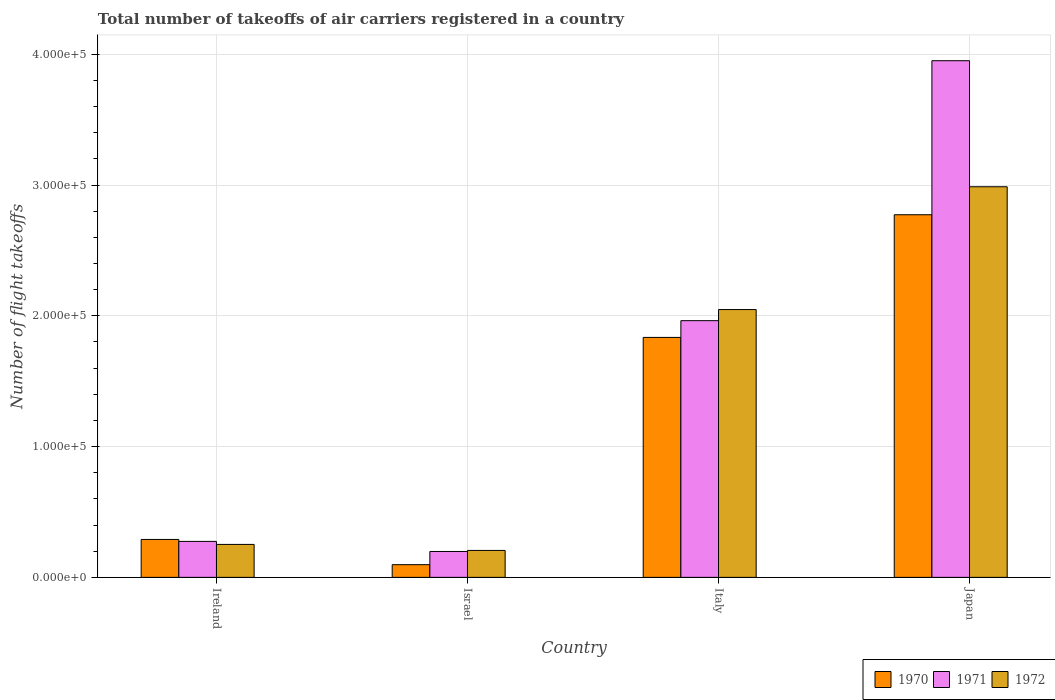How many different coloured bars are there?
Your answer should be compact. 3. How many groups of bars are there?
Provide a succinct answer. 4. How many bars are there on the 4th tick from the left?
Make the answer very short. 3. What is the label of the 2nd group of bars from the left?
Make the answer very short. Israel. In how many cases, is the number of bars for a given country not equal to the number of legend labels?
Your response must be concise. 0. What is the total number of flight takeoffs in 1971 in Italy?
Your response must be concise. 1.96e+05. Across all countries, what is the maximum total number of flight takeoffs in 1972?
Ensure brevity in your answer.  2.99e+05. Across all countries, what is the minimum total number of flight takeoffs in 1972?
Provide a short and direct response. 2.06e+04. In which country was the total number of flight takeoffs in 1970 maximum?
Ensure brevity in your answer.  Japan. In which country was the total number of flight takeoffs in 1972 minimum?
Offer a terse response. Israel. What is the total total number of flight takeoffs in 1970 in the graph?
Provide a succinct answer. 5.00e+05. What is the difference between the total number of flight takeoffs in 1972 in Italy and that in Japan?
Provide a succinct answer. -9.39e+04. What is the difference between the total number of flight takeoffs in 1971 in Ireland and the total number of flight takeoffs in 1970 in Japan?
Give a very brief answer. -2.50e+05. What is the average total number of flight takeoffs in 1970 per country?
Provide a short and direct response. 1.25e+05. What is the difference between the total number of flight takeoffs of/in 1970 and total number of flight takeoffs of/in 1971 in Japan?
Give a very brief answer. -1.18e+05. In how many countries, is the total number of flight takeoffs in 1972 greater than 280000?
Provide a short and direct response. 1. What is the ratio of the total number of flight takeoffs in 1972 in Ireland to that in Japan?
Keep it short and to the point. 0.08. Is the difference between the total number of flight takeoffs in 1970 in Ireland and Israel greater than the difference between the total number of flight takeoffs in 1971 in Ireland and Israel?
Your answer should be very brief. Yes. What is the difference between the highest and the second highest total number of flight takeoffs in 1970?
Your response must be concise. -1.54e+05. What is the difference between the highest and the lowest total number of flight takeoffs in 1972?
Provide a succinct answer. 2.78e+05. Is the sum of the total number of flight takeoffs in 1970 in Ireland and Japan greater than the maximum total number of flight takeoffs in 1972 across all countries?
Provide a short and direct response. Yes. What does the 1st bar from the right in Israel represents?
Your answer should be very brief. 1972. How many bars are there?
Your answer should be compact. 12. Are all the bars in the graph horizontal?
Provide a succinct answer. No. Are the values on the major ticks of Y-axis written in scientific E-notation?
Make the answer very short. Yes. Does the graph contain grids?
Offer a very short reply. Yes. What is the title of the graph?
Your answer should be very brief. Total number of takeoffs of air carriers registered in a country. Does "1988" appear as one of the legend labels in the graph?
Your answer should be compact. No. What is the label or title of the X-axis?
Offer a very short reply. Country. What is the label or title of the Y-axis?
Make the answer very short. Number of flight takeoffs. What is the Number of flight takeoffs of 1970 in Ireland?
Your answer should be compact. 2.90e+04. What is the Number of flight takeoffs in 1971 in Ireland?
Your response must be concise. 2.75e+04. What is the Number of flight takeoffs in 1972 in Ireland?
Provide a succinct answer. 2.52e+04. What is the Number of flight takeoffs in 1970 in Israel?
Offer a very short reply. 9700. What is the Number of flight takeoffs in 1971 in Israel?
Offer a terse response. 1.98e+04. What is the Number of flight takeoffs in 1972 in Israel?
Provide a succinct answer. 2.06e+04. What is the Number of flight takeoffs in 1970 in Italy?
Provide a short and direct response. 1.84e+05. What is the Number of flight takeoffs of 1971 in Italy?
Offer a very short reply. 1.96e+05. What is the Number of flight takeoffs of 1972 in Italy?
Give a very brief answer. 2.05e+05. What is the Number of flight takeoffs of 1970 in Japan?
Provide a succinct answer. 2.77e+05. What is the Number of flight takeoffs of 1971 in Japan?
Provide a short and direct response. 3.95e+05. What is the Number of flight takeoffs of 1972 in Japan?
Give a very brief answer. 2.99e+05. Across all countries, what is the maximum Number of flight takeoffs of 1970?
Offer a terse response. 2.77e+05. Across all countries, what is the maximum Number of flight takeoffs in 1971?
Give a very brief answer. 3.95e+05. Across all countries, what is the maximum Number of flight takeoffs of 1972?
Keep it short and to the point. 2.99e+05. Across all countries, what is the minimum Number of flight takeoffs of 1970?
Provide a succinct answer. 9700. Across all countries, what is the minimum Number of flight takeoffs of 1971?
Ensure brevity in your answer.  1.98e+04. Across all countries, what is the minimum Number of flight takeoffs of 1972?
Keep it short and to the point. 2.06e+04. What is the total Number of flight takeoffs in 1970 in the graph?
Ensure brevity in your answer.  5.00e+05. What is the total Number of flight takeoffs of 1971 in the graph?
Keep it short and to the point. 6.39e+05. What is the total Number of flight takeoffs in 1972 in the graph?
Provide a succinct answer. 5.49e+05. What is the difference between the Number of flight takeoffs of 1970 in Ireland and that in Israel?
Provide a succinct answer. 1.93e+04. What is the difference between the Number of flight takeoffs of 1971 in Ireland and that in Israel?
Your response must be concise. 7700. What is the difference between the Number of flight takeoffs in 1972 in Ireland and that in Israel?
Provide a succinct answer. 4600. What is the difference between the Number of flight takeoffs of 1970 in Ireland and that in Italy?
Your answer should be compact. -1.54e+05. What is the difference between the Number of flight takeoffs of 1971 in Ireland and that in Italy?
Make the answer very short. -1.69e+05. What is the difference between the Number of flight takeoffs of 1972 in Ireland and that in Italy?
Your answer should be very brief. -1.80e+05. What is the difference between the Number of flight takeoffs of 1970 in Ireland and that in Japan?
Your answer should be very brief. -2.48e+05. What is the difference between the Number of flight takeoffs in 1971 in Ireland and that in Japan?
Offer a very short reply. -3.68e+05. What is the difference between the Number of flight takeoffs in 1972 in Ireland and that in Japan?
Offer a terse response. -2.74e+05. What is the difference between the Number of flight takeoffs in 1970 in Israel and that in Italy?
Your answer should be very brief. -1.74e+05. What is the difference between the Number of flight takeoffs of 1971 in Israel and that in Italy?
Your answer should be very brief. -1.76e+05. What is the difference between the Number of flight takeoffs in 1972 in Israel and that in Italy?
Make the answer very short. -1.84e+05. What is the difference between the Number of flight takeoffs of 1970 in Israel and that in Japan?
Your answer should be compact. -2.68e+05. What is the difference between the Number of flight takeoffs in 1971 in Israel and that in Japan?
Keep it short and to the point. -3.75e+05. What is the difference between the Number of flight takeoffs in 1972 in Israel and that in Japan?
Offer a terse response. -2.78e+05. What is the difference between the Number of flight takeoffs of 1970 in Italy and that in Japan?
Your answer should be compact. -9.38e+04. What is the difference between the Number of flight takeoffs of 1971 in Italy and that in Japan?
Ensure brevity in your answer.  -1.99e+05. What is the difference between the Number of flight takeoffs of 1972 in Italy and that in Japan?
Provide a short and direct response. -9.39e+04. What is the difference between the Number of flight takeoffs of 1970 in Ireland and the Number of flight takeoffs of 1971 in Israel?
Your response must be concise. 9200. What is the difference between the Number of flight takeoffs of 1970 in Ireland and the Number of flight takeoffs of 1972 in Israel?
Your response must be concise. 8400. What is the difference between the Number of flight takeoffs in 1971 in Ireland and the Number of flight takeoffs in 1972 in Israel?
Offer a very short reply. 6900. What is the difference between the Number of flight takeoffs in 1970 in Ireland and the Number of flight takeoffs in 1971 in Italy?
Give a very brief answer. -1.67e+05. What is the difference between the Number of flight takeoffs in 1970 in Ireland and the Number of flight takeoffs in 1972 in Italy?
Your response must be concise. -1.76e+05. What is the difference between the Number of flight takeoffs in 1971 in Ireland and the Number of flight takeoffs in 1972 in Italy?
Offer a very short reply. -1.77e+05. What is the difference between the Number of flight takeoffs of 1970 in Ireland and the Number of flight takeoffs of 1971 in Japan?
Give a very brief answer. -3.66e+05. What is the difference between the Number of flight takeoffs in 1970 in Ireland and the Number of flight takeoffs in 1972 in Japan?
Your answer should be very brief. -2.70e+05. What is the difference between the Number of flight takeoffs of 1971 in Ireland and the Number of flight takeoffs of 1972 in Japan?
Ensure brevity in your answer.  -2.71e+05. What is the difference between the Number of flight takeoffs in 1970 in Israel and the Number of flight takeoffs in 1971 in Italy?
Your answer should be compact. -1.87e+05. What is the difference between the Number of flight takeoffs in 1970 in Israel and the Number of flight takeoffs in 1972 in Italy?
Give a very brief answer. -1.95e+05. What is the difference between the Number of flight takeoffs in 1971 in Israel and the Number of flight takeoffs in 1972 in Italy?
Offer a terse response. -1.85e+05. What is the difference between the Number of flight takeoffs in 1970 in Israel and the Number of flight takeoffs in 1971 in Japan?
Offer a very short reply. -3.85e+05. What is the difference between the Number of flight takeoffs in 1970 in Israel and the Number of flight takeoffs in 1972 in Japan?
Offer a very short reply. -2.89e+05. What is the difference between the Number of flight takeoffs of 1971 in Israel and the Number of flight takeoffs of 1972 in Japan?
Offer a terse response. -2.79e+05. What is the difference between the Number of flight takeoffs in 1970 in Italy and the Number of flight takeoffs in 1971 in Japan?
Make the answer very short. -2.12e+05. What is the difference between the Number of flight takeoffs of 1970 in Italy and the Number of flight takeoffs of 1972 in Japan?
Your answer should be very brief. -1.15e+05. What is the difference between the Number of flight takeoffs in 1971 in Italy and the Number of flight takeoffs in 1972 in Japan?
Offer a terse response. -1.02e+05. What is the average Number of flight takeoffs in 1970 per country?
Make the answer very short. 1.25e+05. What is the average Number of flight takeoffs in 1971 per country?
Provide a short and direct response. 1.60e+05. What is the average Number of flight takeoffs of 1972 per country?
Make the answer very short. 1.37e+05. What is the difference between the Number of flight takeoffs of 1970 and Number of flight takeoffs of 1971 in Ireland?
Your answer should be very brief. 1500. What is the difference between the Number of flight takeoffs of 1970 and Number of flight takeoffs of 1972 in Ireland?
Ensure brevity in your answer.  3800. What is the difference between the Number of flight takeoffs of 1971 and Number of flight takeoffs of 1972 in Ireland?
Give a very brief answer. 2300. What is the difference between the Number of flight takeoffs in 1970 and Number of flight takeoffs in 1971 in Israel?
Your answer should be very brief. -1.01e+04. What is the difference between the Number of flight takeoffs of 1970 and Number of flight takeoffs of 1972 in Israel?
Your answer should be very brief. -1.09e+04. What is the difference between the Number of flight takeoffs of 1971 and Number of flight takeoffs of 1972 in Israel?
Offer a very short reply. -800. What is the difference between the Number of flight takeoffs in 1970 and Number of flight takeoffs in 1971 in Italy?
Your response must be concise. -1.28e+04. What is the difference between the Number of flight takeoffs in 1970 and Number of flight takeoffs in 1972 in Italy?
Give a very brief answer. -2.13e+04. What is the difference between the Number of flight takeoffs in 1971 and Number of flight takeoffs in 1972 in Italy?
Provide a succinct answer. -8500. What is the difference between the Number of flight takeoffs of 1970 and Number of flight takeoffs of 1971 in Japan?
Provide a succinct answer. -1.18e+05. What is the difference between the Number of flight takeoffs of 1970 and Number of flight takeoffs of 1972 in Japan?
Provide a short and direct response. -2.14e+04. What is the difference between the Number of flight takeoffs in 1971 and Number of flight takeoffs in 1972 in Japan?
Ensure brevity in your answer.  9.64e+04. What is the ratio of the Number of flight takeoffs in 1970 in Ireland to that in Israel?
Offer a terse response. 2.99. What is the ratio of the Number of flight takeoffs in 1971 in Ireland to that in Israel?
Give a very brief answer. 1.39. What is the ratio of the Number of flight takeoffs of 1972 in Ireland to that in Israel?
Provide a succinct answer. 1.22. What is the ratio of the Number of flight takeoffs in 1970 in Ireland to that in Italy?
Give a very brief answer. 0.16. What is the ratio of the Number of flight takeoffs in 1971 in Ireland to that in Italy?
Keep it short and to the point. 0.14. What is the ratio of the Number of flight takeoffs of 1972 in Ireland to that in Italy?
Offer a very short reply. 0.12. What is the ratio of the Number of flight takeoffs in 1970 in Ireland to that in Japan?
Provide a succinct answer. 0.1. What is the ratio of the Number of flight takeoffs of 1971 in Ireland to that in Japan?
Provide a succinct answer. 0.07. What is the ratio of the Number of flight takeoffs in 1972 in Ireland to that in Japan?
Provide a short and direct response. 0.08. What is the ratio of the Number of flight takeoffs of 1970 in Israel to that in Italy?
Your answer should be very brief. 0.05. What is the ratio of the Number of flight takeoffs of 1971 in Israel to that in Italy?
Keep it short and to the point. 0.1. What is the ratio of the Number of flight takeoffs in 1972 in Israel to that in Italy?
Provide a succinct answer. 0.1. What is the ratio of the Number of flight takeoffs of 1970 in Israel to that in Japan?
Keep it short and to the point. 0.04. What is the ratio of the Number of flight takeoffs of 1971 in Israel to that in Japan?
Offer a terse response. 0.05. What is the ratio of the Number of flight takeoffs in 1972 in Israel to that in Japan?
Make the answer very short. 0.07. What is the ratio of the Number of flight takeoffs in 1970 in Italy to that in Japan?
Offer a terse response. 0.66. What is the ratio of the Number of flight takeoffs in 1971 in Italy to that in Japan?
Provide a succinct answer. 0.5. What is the ratio of the Number of flight takeoffs in 1972 in Italy to that in Japan?
Your response must be concise. 0.69. What is the difference between the highest and the second highest Number of flight takeoffs of 1970?
Provide a succinct answer. 9.38e+04. What is the difference between the highest and the second highest Number of flight takeoffs in 1971?
Ensure brevity in your answer.  1.99e+05. What is the difference between the highest and the second highest Number of flight takeoffs in 1972?
Provide a succinct answer. 9.39e+04. What is the difference between the highest and the lowest Number of flight takeoffs in 1970?
Offer a very short reply. 2.68e+05. What is the difference between the highest and the lowest Number of flight takeoffs in 1971?
Offer a terse response. 3.75e+05. What is the difference between the highest and the lowest Number of flight takeoffs in 1972?
Provide a short and direct response. 2.78e+05. 